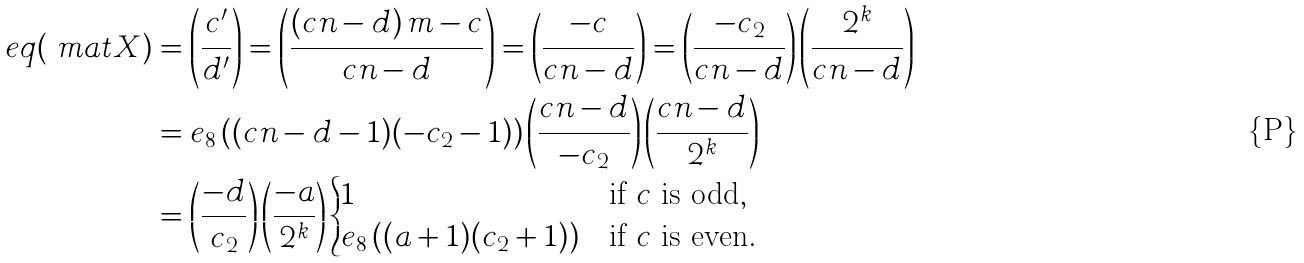Convert formula to latex. <formula><loc_0><loc_0><loc_500><loc_500>\ e q ( \ m a t { X } ) & = \left ( \frac { c ^ { \prime } } { d ^ { \prime } } \right ) = \left ( \frac { \left ( c n - d \right ) m - c } { c n - d } \right ) = \left ( \frac { - c } { c n - d } \right ) = \left ( \frac { - c _ { 2 } } { c n - d } \right ) \left ( \frac { 2 ^ { k } } { c n - d } \right ) \\ & = e _ { 8 } \left ( ( c n - d - 1 ) ( - c _ { 2 } - 1 ) \right ) \left ( \frac { c n - d } { - c _ { 2 } } \right ) \left ( \frac { c n - d } { 2 ^ { k } } \right ) \\ & = \left ( \frac { - d } { c _ { 2 } } \right ) \left ( \frac { - a } { 2 ^ { k } } \right ) \begin{cases} 1 & \text {if $c$ is odd} , \\ e _ { 8 } \left ( ( a + 1 ) ( c _ { 2 } + 1 ) \right ) & \text {if $c$ is even} . \end{cases}</formula> 